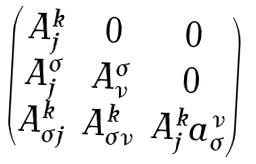Convert formula to latex. <formula><loc_0><loc_0><loc_500><loc_500>\begin{pmatrix} A ^ { k } _ { j } & 0 & 0 \\ A ^ { \sigma } _ { j } & A ^ { \sigma } _ { \nu } & 0 \\ A ^ { k } _ { \sigma j } & A ^ { k } _ { \sigma \nu } & A ^ { k } _ { j } a ^ { \nu } _ { \sigma } \end{pmatrix}</formula> 